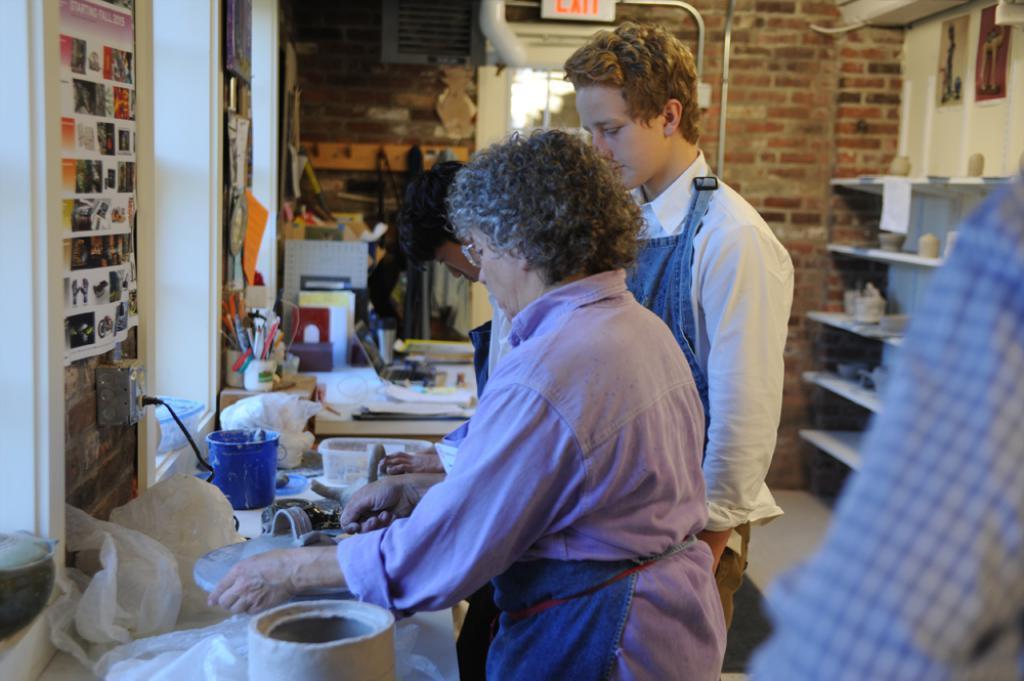In one or two sentences, can you explain what this image depicts? In this image we can see a few people standing, in front of them, there is a table, on the table, we can see the bucket, papers, laptop and some other objects, also we can see some posters, there are shelves with some objects on it and in the background we can see the wall and an exit board. 